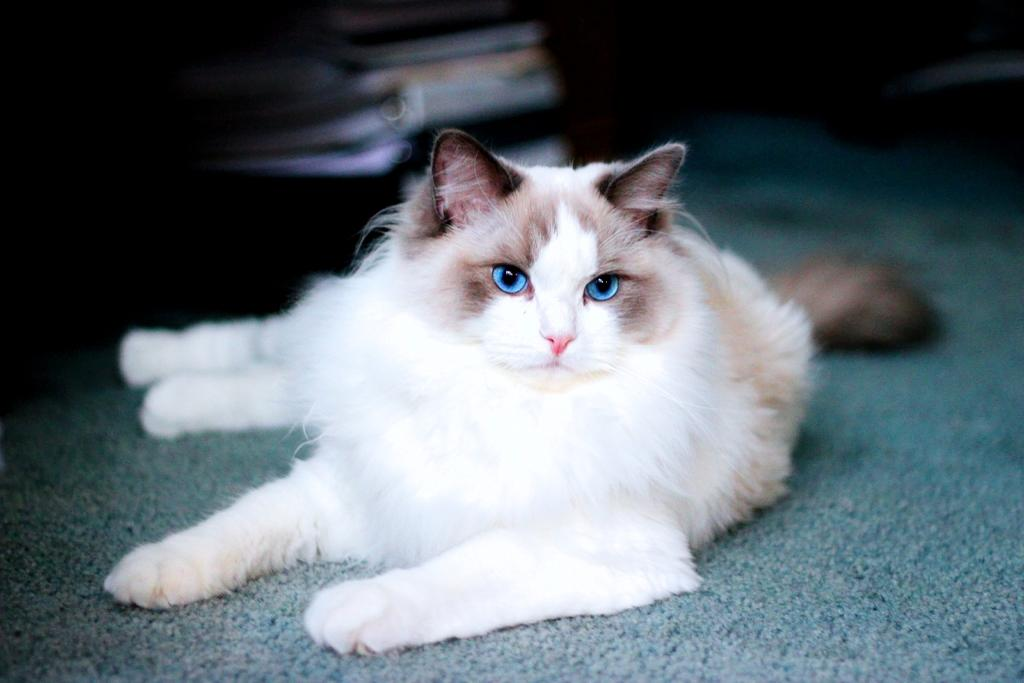What animal is present in the image? There is a cat in the image. Where is the cat located? The cat is on a surface. Can you describe the background of the image? The background of the image is blurry. What type of pie is the cat eating in the image? There is no pie present in the image; it features a cat on a surface with a blurry background. 